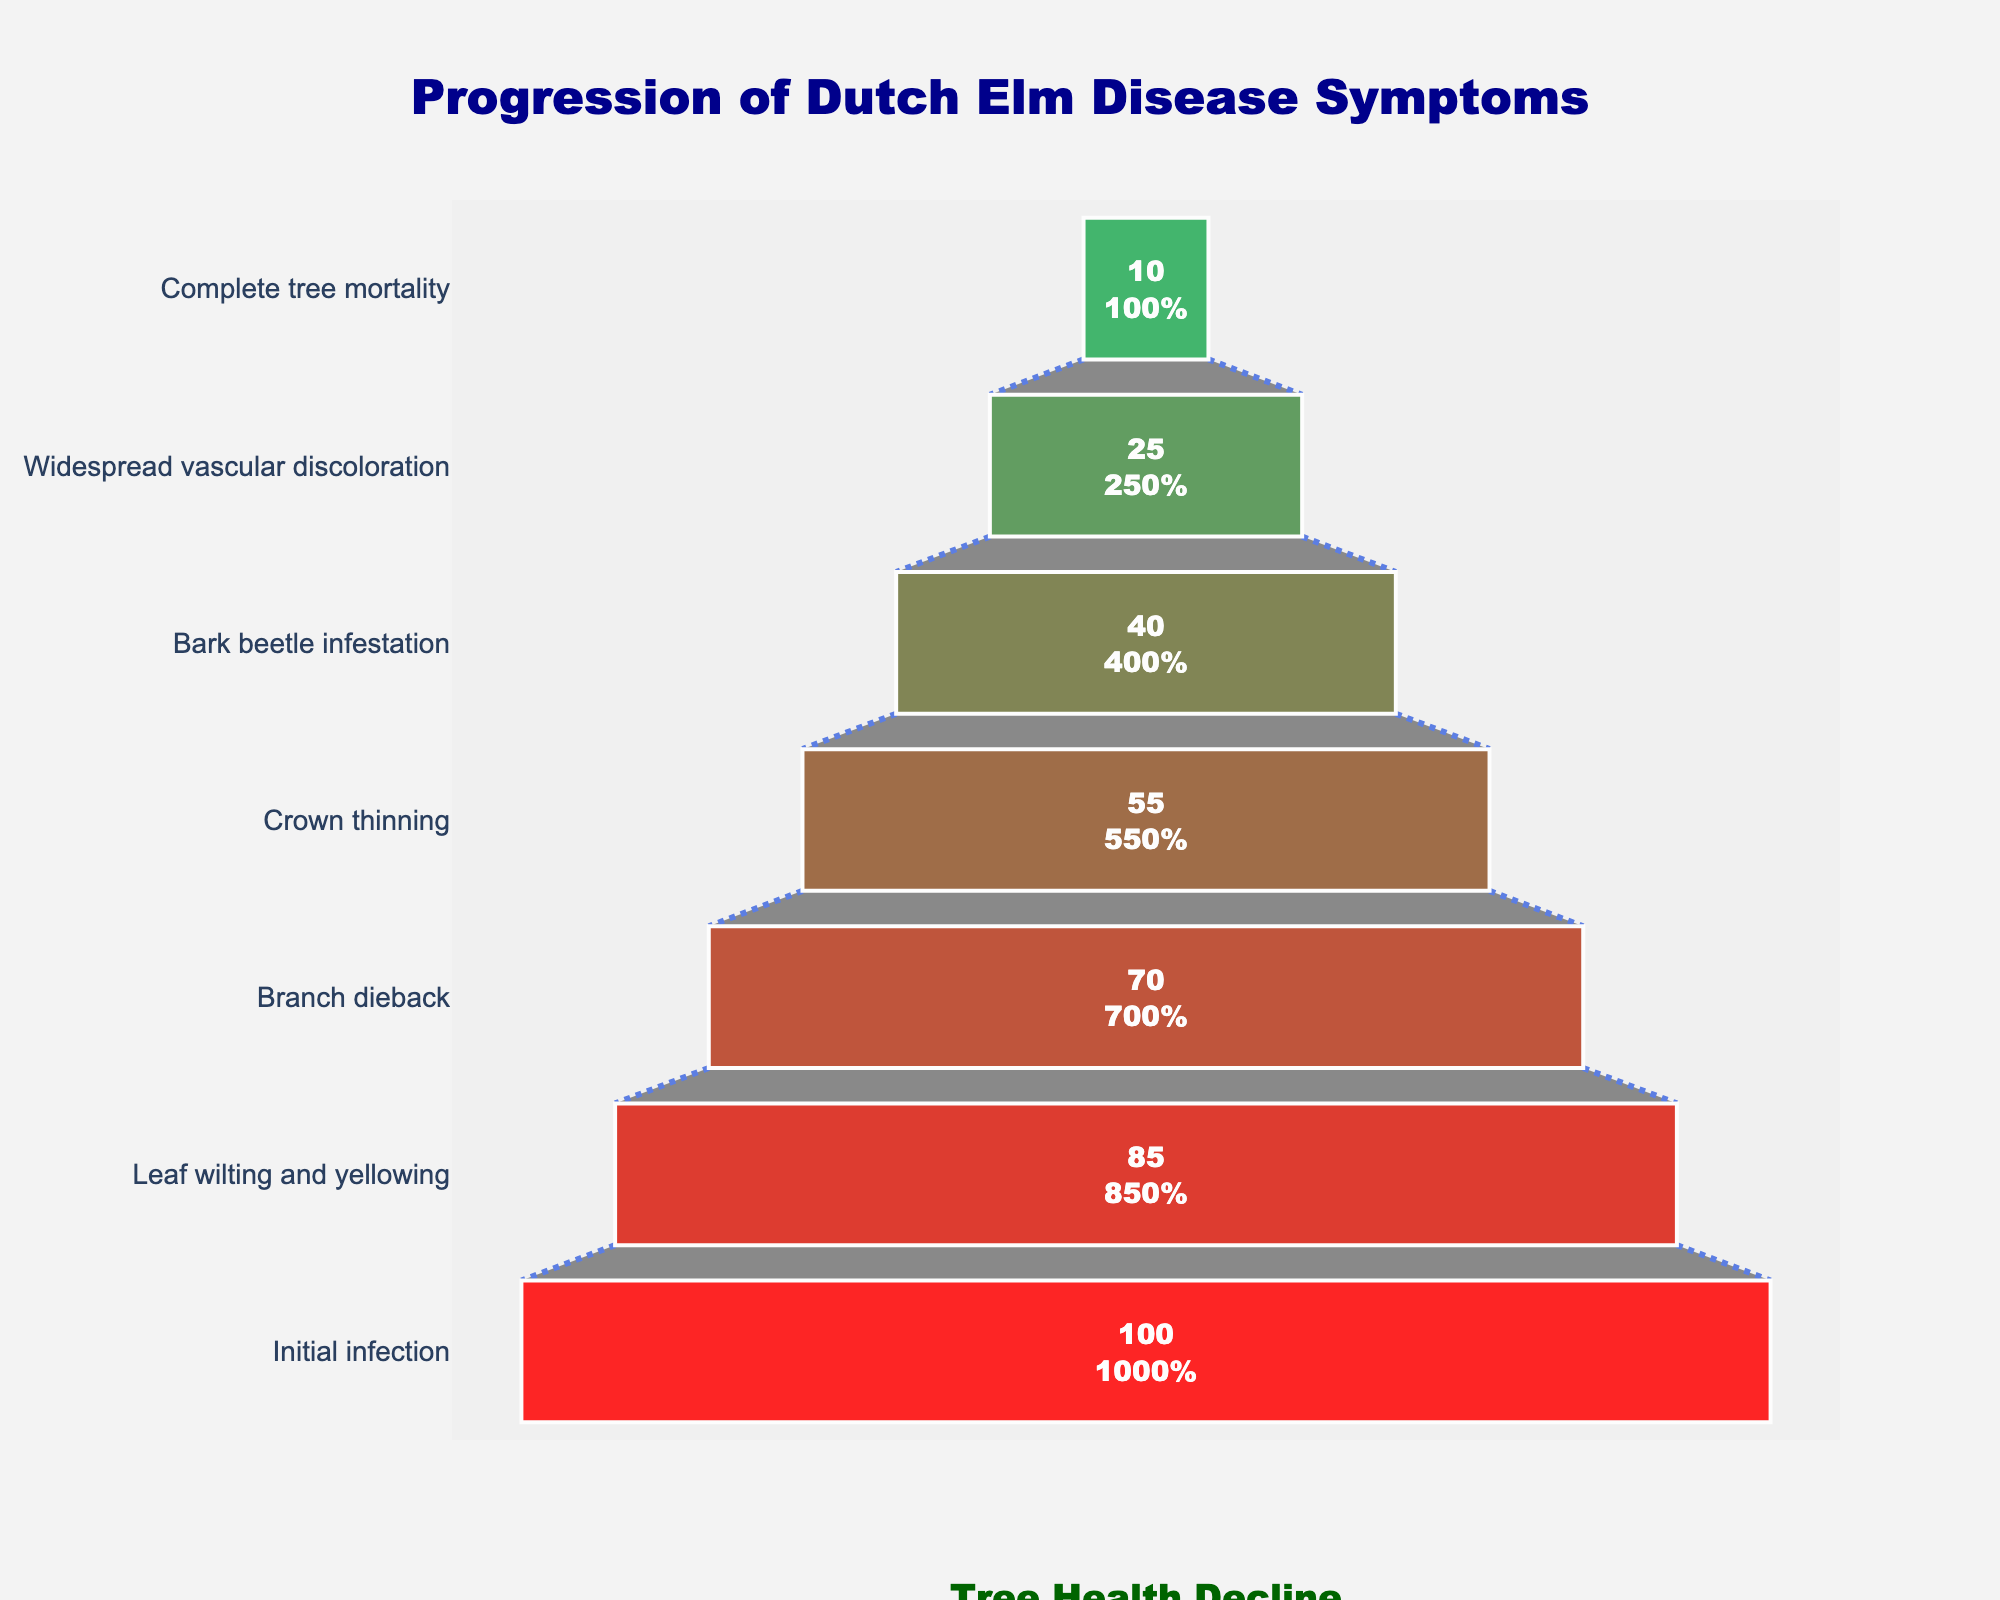What is the title of the figure? The title of the figure can be found at the top, usually centered. It states, "Progression of Dutch Elm Disease Symptoms".
Answer: Progression of Dutch Elm Disease Symptoms How many stages of symptoms are shown in the figure? To determine this, count the number of different stages listed on the y-axis of the funnel chart. There are seven stages.
Answer: Seven Which stage shows the highest percentage of trees affected? Look for the largest percentage at the top of the funnel chart. The stage "Initial infection" has the highest percentage of trees affected, which is 100%.
Answer: Initial infection What percentage of trees are affected at the "Crown thinning" stage? Find the "Crown thinning" label on the y-axis and read the corresponding percentage on the x-axis. This is 55%.
Answer: 55% What is the percentage decrease in trees affected from "Branch dieback" to "Bark beetle infestation"? Subtract the percentage of trees affected at the "Bark beetle infestation" stage (40%) from the "Branch dieback" stage (70%). The decrease is 70% - 40% = 30%.
Answer: 30% Which stage sees the greatest drop in the percentage of trees affected compared to the previous stage? Compare the differences between consecutive stages. The greatest drop is from "Initial infection" (100%) to "Leaf wilting and yellowing" (85%), a decrease of 15% (100% - 85%).
Answer: Initial infection to Leaf wilting and yellowing What is the median percentage of trees affected across all stages? List the percentages (10%, 25%, 40%, 55%, 70%, 85%, 100%) and find the middle value when ordered. The median value is 55%.
Answer: 55% How does the percentage of trees affected at the "Widespread vascular discoloration" stage compare to the "Complete tree mortality" stage? Check the percentages for "Widespread vascular discoloration" (25%) and "Complete tree mortality" (10%) stages. The "Widespread vascular discoloration" stage has a higher percentage of trees affected (25%) compared to the "Complete tree mortality" stage (10%).
Answer: Widespread vascular discoloration is higher What is the total percentage decrease in trees affected from the "Initial infection" stage to the "Complete tree mortality" stage? Subtract the percentage of "Complete tree mortality" (10%) from the "Initial infection" (100%) to get the total decrease: 100% - 10% = 90%.
Answer: 90% What is the difference in the percentage of trees affected between the "Crown thinning" and "Branch dieback" stages? Subtract the percentage at "Crown thinning" (55%) from that at "Branch dieback" (70%). This is 70% - 55% = 15%.
Answer: 15% 